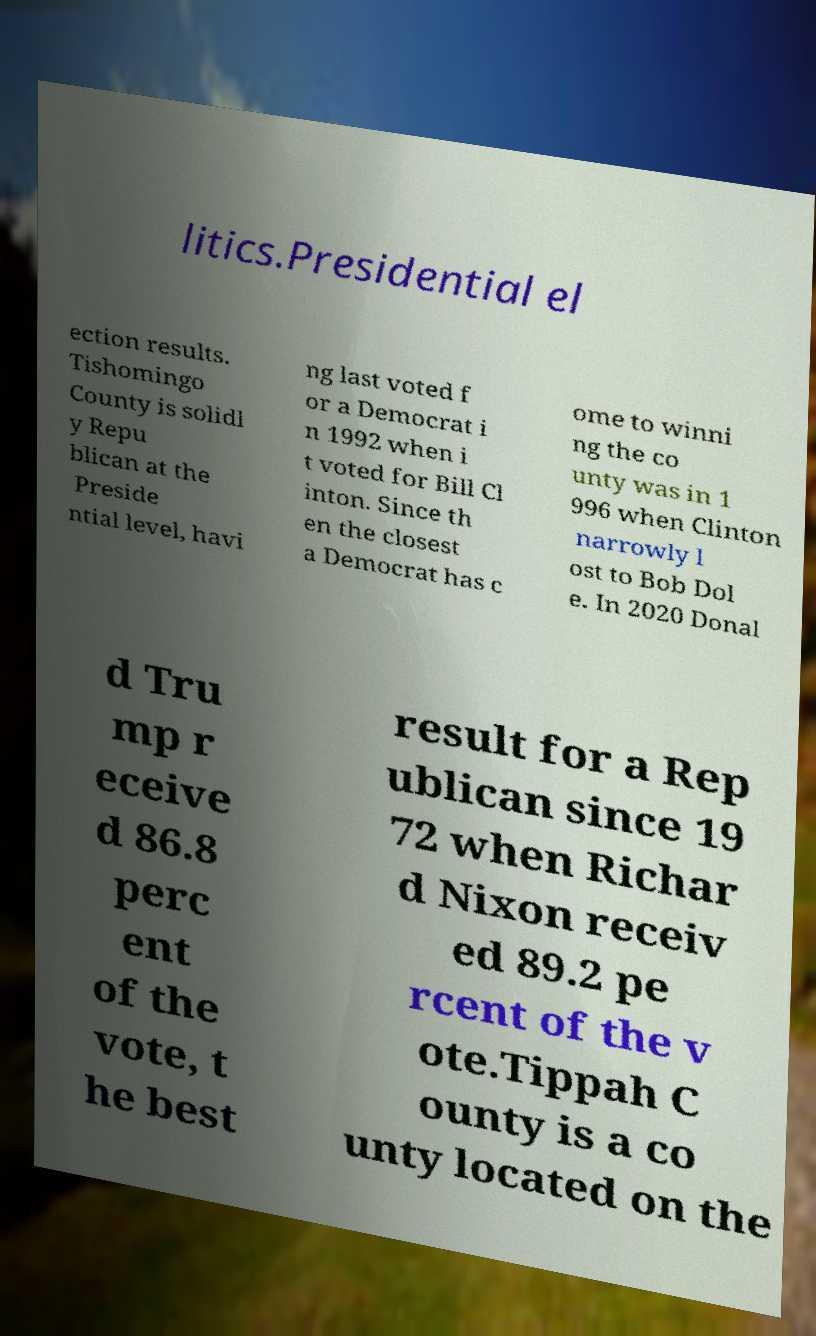What messages or text are displayed in this image? I need them in a readable, typed format. litics.Presidential el ection results. Tishomingo County is solidl y Repu blican at the Preside ntial level, havi ng last voted f or a Democrat i n 1992 when i t voted for Bill Cl inton. Since th en the closest a Democrat has c ome to winni ng the co unty was in 1 996 when Clinton narrowly l ost to Bob Dol e. In 2020 Donal d Tru mp r eceive d 86.8 perc ent of the vote, t he best result for a Rep ublican since 19 72 when Richar d Nixon receiv ed 89.2 pe rcent of the v ote.Tippah C ounty is a co unty located on the 